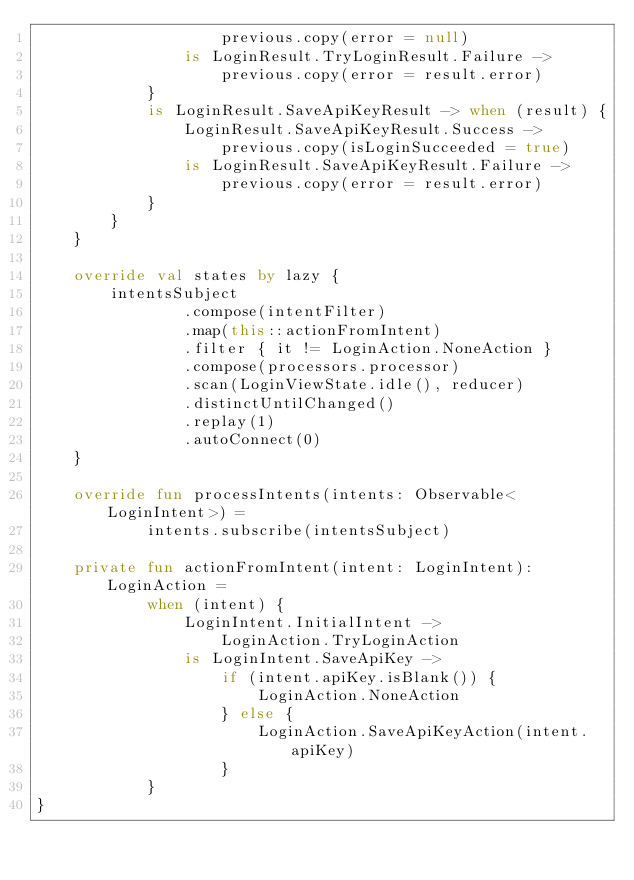Convert code to text. <code><loc_0><loc_0><loc_500><loc_500><_Kotlin_>                    previous.copy(error = null)
                is LoginResult.TryLoginResult.Failure ->
                    previous.copy(error = result.error)
            }
            is LoginResult.SaveApiKeyResult -> when (result) {
                LoginResult.SaveApiKeyResult.Success ->
                    previous.copy(isLoginSucceeded = true)
                is LoginResult.SaveApiKeyResult.Failure ->
                    previous.copy(error = result.error)
            }
        }
    }

    override val states by lazy {
        intentsSubject
                .compose(intentFilter)
                .map(this::actionFromIntent)
                .filter { it != LoginAction.NoneAction }
                .compose(processors.processor)
                .scan(LoginViewState.idle(), reducer)
                .distinctUntilChanged()
                .replay(1)
                .autoConnect(0)
    }

    override fun processIntents(intents: Observable<LoginIntent>) =
            intents.subscribe(intentsSubject)

    private fun actionFromIntent(intent: LoginIntent): LoginAction =
            when (intent) {
                LoginIntent.InitialIntent ->
                    LoginAction.TryLoginAction
                is LoginIntent.SaveApiKey ->
                    if (intent.apiKey.isBlank()) {
                        LoginAction.NoneAction
                    } else {
                        LoginAction.SaveApiKeyAction(intent.apiKey)
                    }
            }
}
</code> 